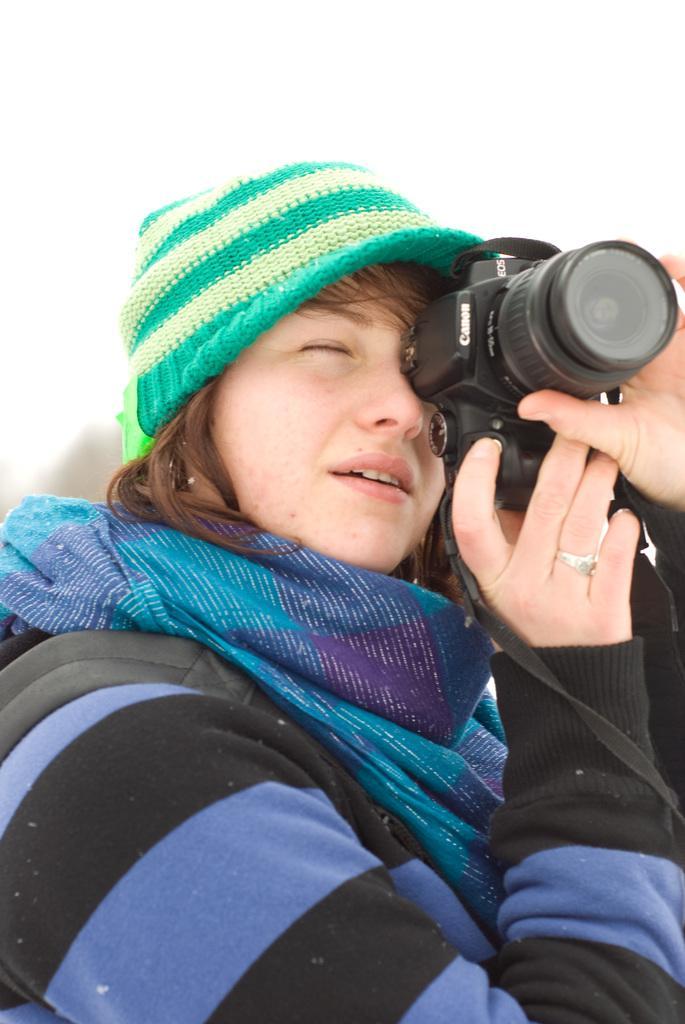Describe this image in one or two sentences. This is the picture of a women in a sweater wearing a blue color scarf and a hat. The woman is holding a canon black camera. To her right hand she is having a ring. Behind the woman is a wall. 